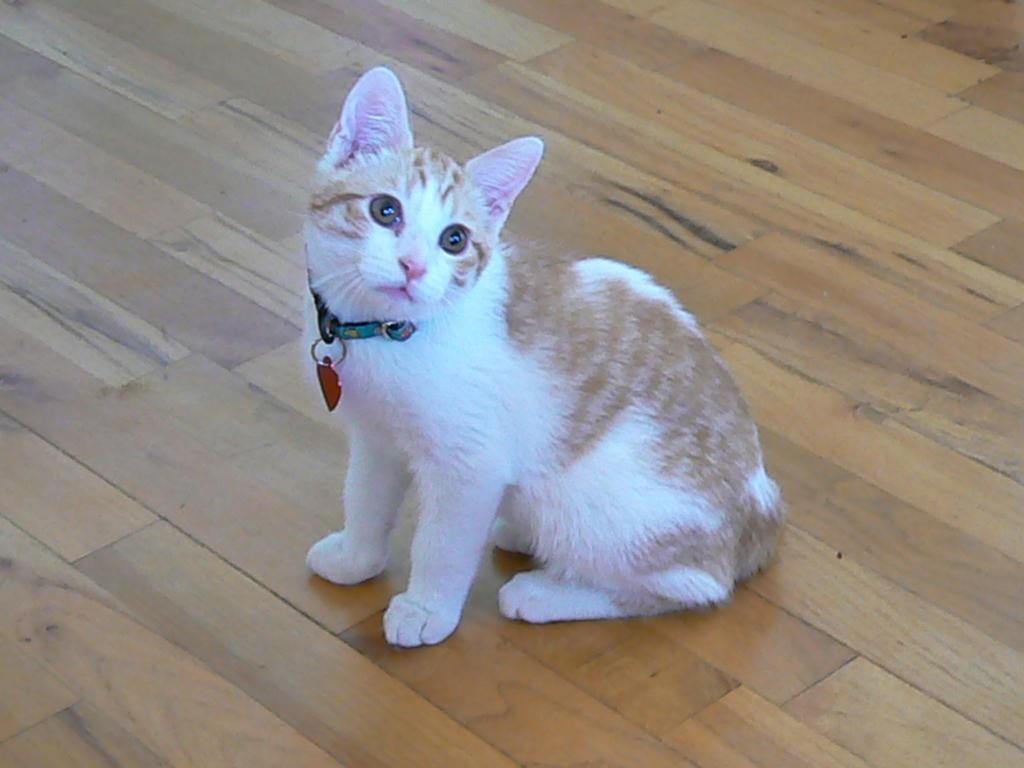What type of animal is in the picture? There is a white cat in the picture. What is the cat doing in the image? The cat is staring at something. What colors are on the cat's belt? The cat's belt has black, red, and blue colors. What type of flooring is visible at the bottom of the image? There is a wooden floor visible at the bottom of the image. How many children are playing with the snake in the image? There are no children or snakes present in the image; it features a white cat staring at something. 